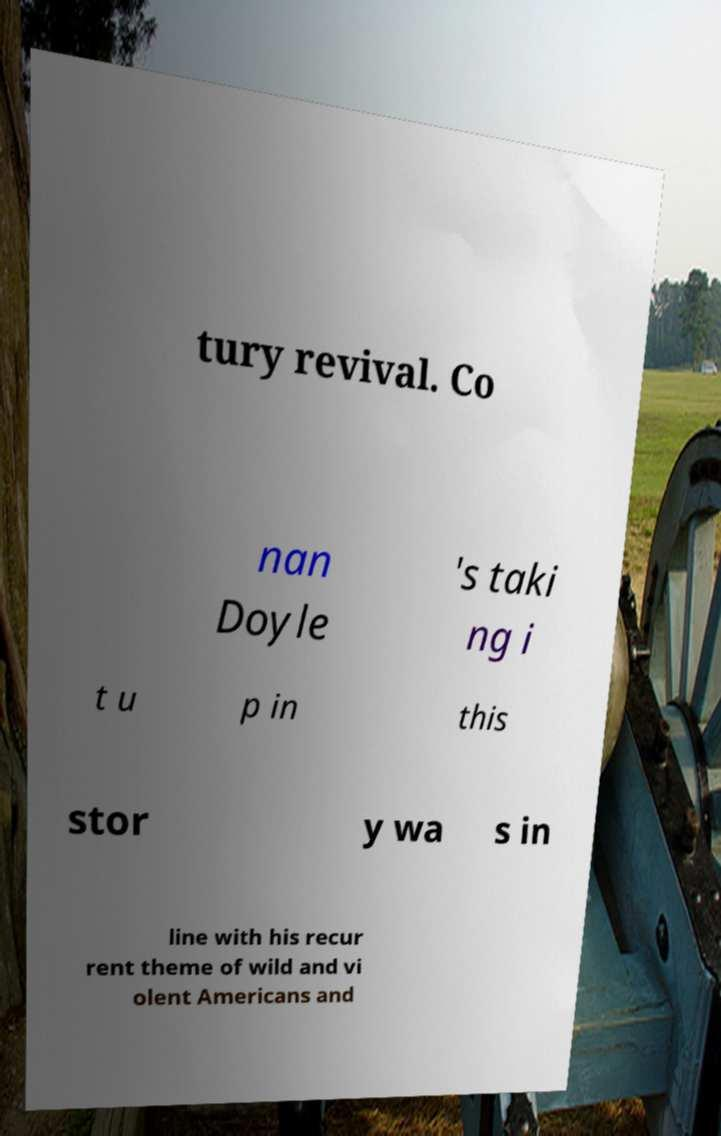Can you read and provide the text displayed in the image?This photo seems to have some interesting text. Can you extract and type it out for me? tury revival. Co nan Doyle 's taki ng i t u p in this stor y wa s in line with his recur rent theme of wild and vi olent Americans and 